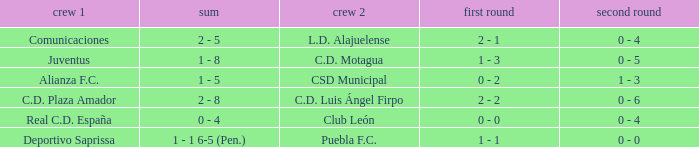Could you parse the entire table? {'header': ['crew 1', 'sum', 'crew 2', 'first round', 'second round'], 'rows': [['Comunicaciones', '2 - 5', 'L.D. Alajuelense', '2 - 1', '0 - 4'], ['Juventus', '1 - 8', 'C.D. Motagua', '1 - 3', '0 - 5'], ['Alianza F.C.', '1 - 5', 'CSD Municipal', '0 - 2', '1 - 3'], ['C.D. Plaza Amador', '2 - 8', 'C.D. Luis Ángel Firpo', '2 - 2', '0 - 6'], ['Real C.D. España', '0 - 4', 'Club León', '0 - 0', '0 - 4'], ['Deportivo Saprissa', '1 - 1 6-5 (Pen.)', 'Puebla F.C.', '1 - 1', '0 - 0']]} What is the 2nd leg of the Comunicaciones team? 0 - 4. 